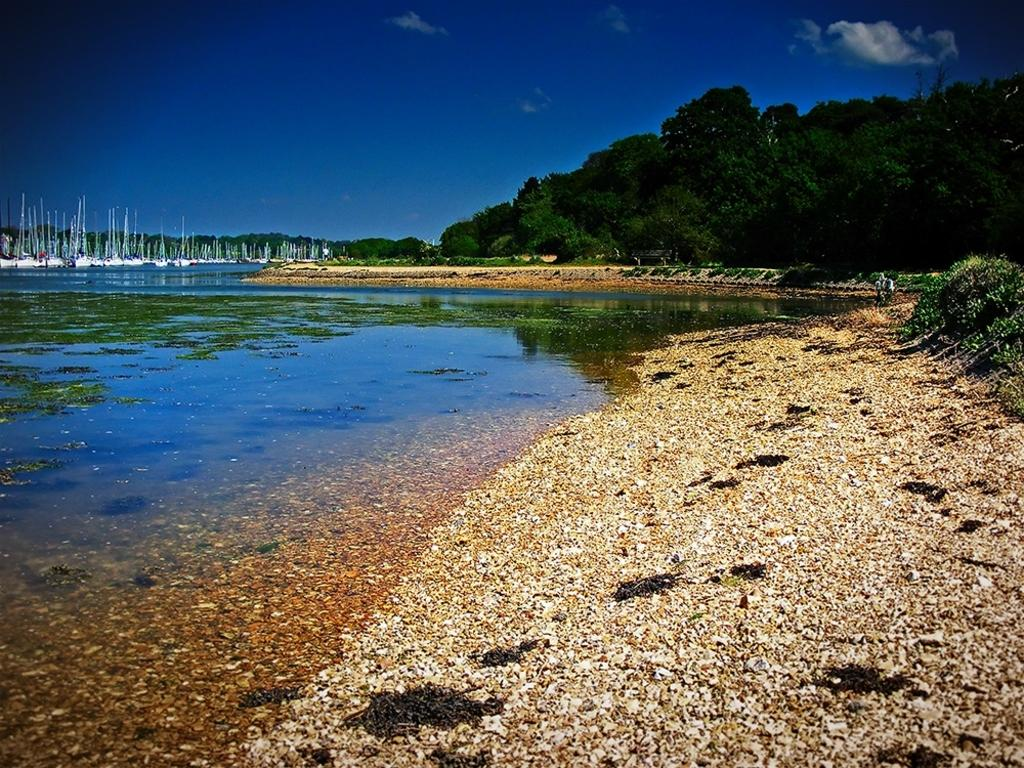What can be seen in the background of the image? There is a sky in the image. What structures are present in the image? There are poles in the image. What type of vegetation is visible in the image? There are trees in the image. What natural feature is present in the image? There is a river in the image. What type of force is being exerted on the river in the image? There is no indication of any force being exerted on the river in the image. 